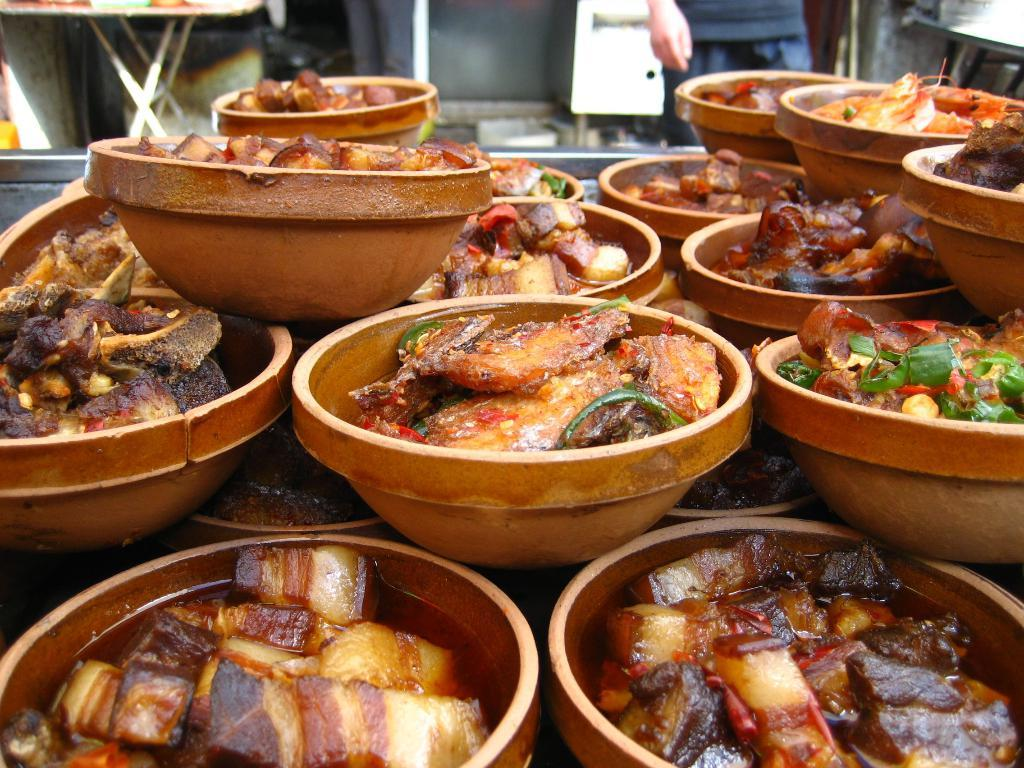How many bowls are visible in the image? There are many bowls in the image. What is inside the bowls? There is food in the bowls. Can you describe the person in the image? There is a person standing in the top right corner of the image. What team is the person in the image supporting? There is no indication of a team or any sports-related context in the image. 